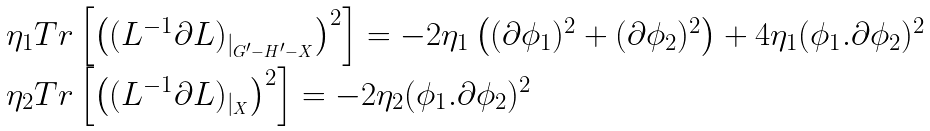<formula> <loc_0><loc_0><loc_500><loc_500>\begin{array} { l } \eta _ { 1 } T r \left [ \left ( ( L ^ { - 1 } \partial L ) _ { | _ { G ^ { \prime } - H ^ { \prime } - X } } \right ) ^ { 2 } \right ] = - 2 \eta _ { 1 } \left ( ( \partial \phi _ { 1 } ) ^ { 2 } + ( \partial \phi _ { 2 } ) ^ { 2 } \right ) + 4 \eta _ { 1 } ( \phi _ { 1 } . \partial \phi _ { 2 } ) ^ { 2 } \\ \eta _ { 2 } T r \left [ \left ( ( L ^ { - 1 } \partial L ) _ { | _ { X } } \right ) ^ { 2 } \right ] = - 2 \eta _ { 2 } ( \phi _ { 1 } . \partial \phi _ { 2 } ) ^ { 2 } \end{array}</formula> 